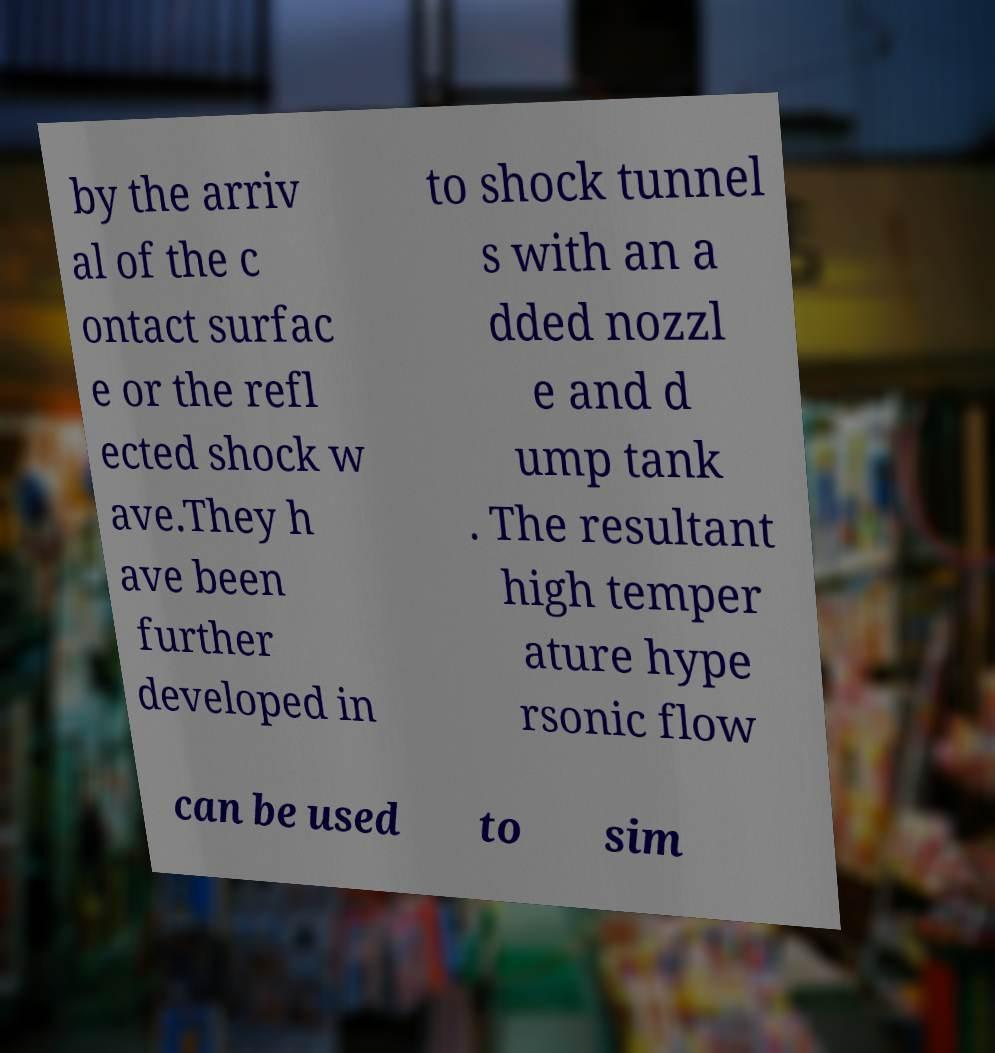There's text embedded in this image that I need extracted. Can you transcribe it verbatim? by the arriv al of the c ontact surfac e or the refl ected shock w ave.They h ave been further developed in to shock tunnel s with an a dded nozzl e and d ump tank . The resultant high temper ature hype rsonic flow can be used to sim 